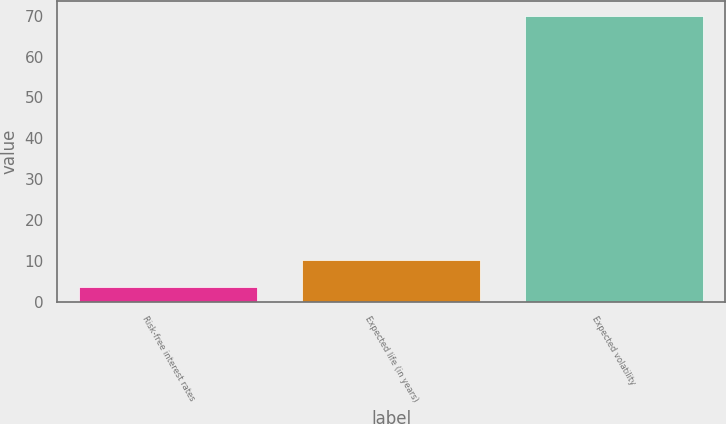<chart> <loc_0><loc_0><loc_500><loc_500><bar_chart><fcel>Risk-free interest rates<fcel>Expected life (in years)<fcel>Expected volatility<nl><fcel>3.7<fcel>10.33<fcel>70<nl></chart> 